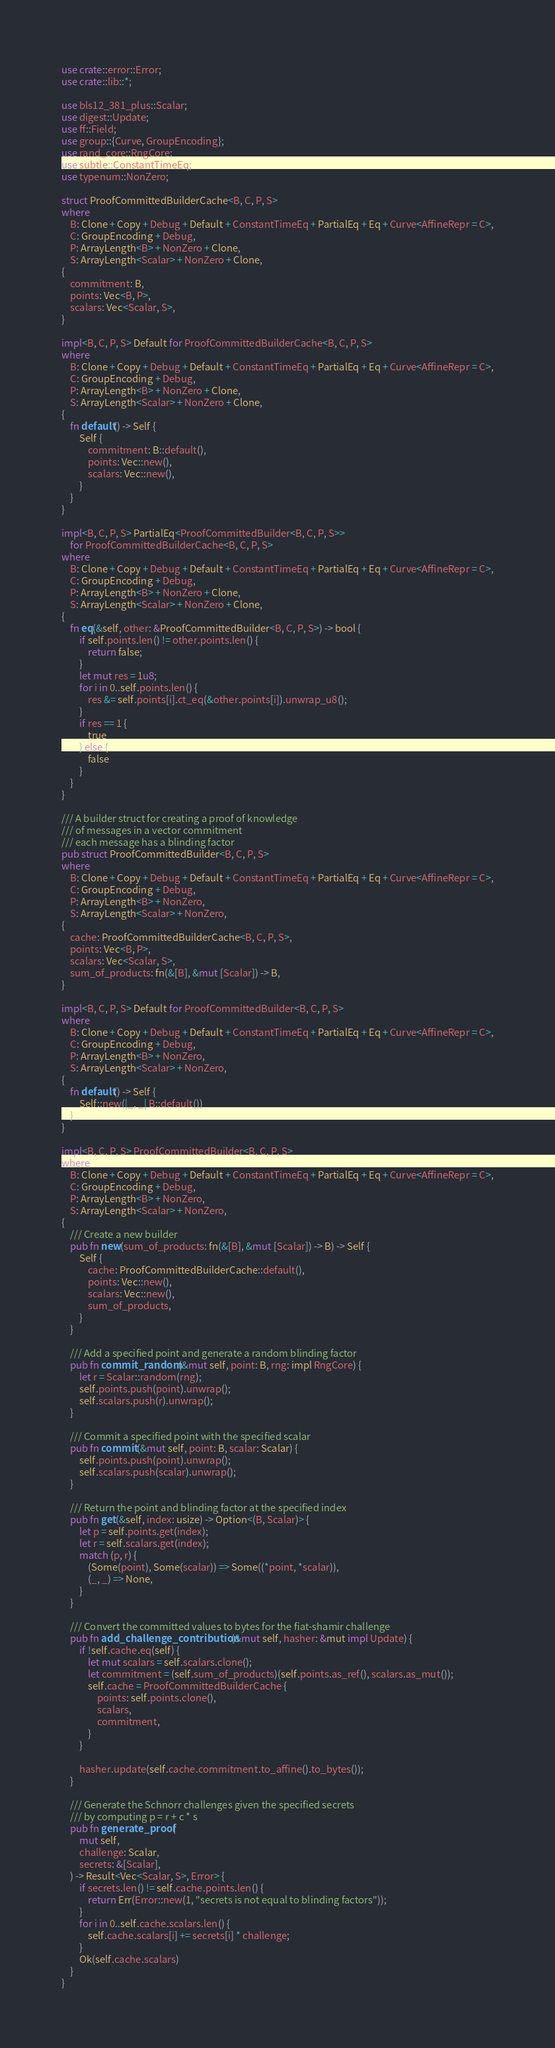<code> <loc_0><loc_0><loc_500><loc_500><_Rust_>use crate::error::Error;
use crate::lib::*;

use bls12_381_plus::Scalar;
use digest::Update;
use ff::Field;
use group::{Curve, GroupEncoding};
use rand_core::RngCore;
use subtle::ConstantTimeEq;
use typenum::NonZero;

struct ProofCommittedBuilderCache<B, C, P, S>
where
    B: Clone + Copy + Debug + Default + ConstantTimeEq + PartialEq + Eq + Curve<AffineRepr = C>,
    C: GroupEncoding + Debug,
    P: ArrayLength<B> + NonZero + Clone,
    S: ArrayLength<Scalar> + NonZero + Clone,
{
    commitment: B,
    points: Vec<B, P>,
    scalars: Vec<Scalar, S>,
}

impl<B, C, P, S> Default for ProofCommittedBuilderCache<B, C, P, S>
where
    B: Clone + Copy + Debug + Default + ConstantTimeEq + PartialEq + Eq + Curve<AffineRepr = C>,
    C: GroupEncoding + Debug,
    P: ArrayLength<B> + NonZero + Clone,
    S: ArrayLength<Scalar> + NonZero + Clone,
{
    fn default() -> Self {
        Self {
            commitment: B::default(),
            points: Vec::new(),
            scalars: Vec::new(),
        }
    }
}

impl<B, C, P, S> PartialEq<ProofCommittedBuilder<B, C, P, S>>
    for ProofCommittedBuilderCache<B, C, P, S>
where
    B: Clone + Copy + Debug + Default + ConstantTimeEq + PartialEq + Eq + Curve<AffineRepr = C>,
    C: GroupEncoding + Debug,
    P: ArrayLength<B> + NonZero + Clone,
    S: ArrayLength<Scalar> + NonZero + Clone,
{
    fn eq(&self, other: &ProofCommittedBuilder<B, C, P, S>) -> bool {
        if self.points.len() != other.points.len() {
            return false;
        }
        let mut res = 1u8;
        for i in 0..self.points.len() {
            res &= self.points[i].ct_eq(&other.points[i]).unwrap_u8();
        }
        if res == 1 {
            true
        } else {
            false
        }
    }
}

/// A builder struct for creating a proof of knowledge
/// of messages in a vector commitment
/// each message has a blinding factor
pub struct ProofCommittedBuilder<B, C, P, S>
where
    B: Clone + Copy + Debug + Default + ConstantTimeEq + PartialEq + Eq + Curve<AffineRepr = C>,
    C: GroupEncoding + Debug,
    P: ArrayLength<B> + NonZero,
    S: ArrayLength<Scalar> + NonZero,
{
    cache: ProofCommittedBuilderCache<B, C, P, S>,
    points: Vec<B, P>,
    scalars: Vec<Scalar, S>,
    sum_of_products: fn(&[B], &mut [Scalar]) -> B,
}

impl<B, C, P, S> Default for ProofCommittedBuilder<B, C, P, S>
where
    B: Clone + Copy + Debug + Default + ConstantTimeEq + PartialEq + Eq + Curve<AffineRepr = C>,
    C: GroupEncoding + Debug,
    P: ArrayLength<B> + NonZero,
    S: ArrayLength<Scalar> + NonZero,
{
    fn default() -> Self {
        Self::new(|_, _| B::default())
    }
}

impl<B, C, P, S> ProofCommittedBuilder<B, C, P, S>
where
    B: Clone + Copy + Debug + Default + ConstantTimeEq + PartialEq + Eq + Curve<AffineRepr = C>,
    C: GroupEncoding + Debug,
    P: ArrayLength<B> + NonZero,
    S: ArrayLength<Scalar> + NonZero,
{
    /// Create a new builder
    pub fn new(sum_of_products: fn(&[B], &mut [Scalar]) -> B) -> Self {
        Self {
            cache: ProofCommittedBuilderCache::default(),
            points: Vec::new(),
            scalars: Vec::new(),
            sum_of_products,
        }
    }

    /// Add a specified point and generate a random blinding factor
    pub fn commit_random(&mut self, point: B, rng: impl RngCore) {
        let r = Scalar::random(rng);
        self.points.push(point).unwrap();
        self.scalars.push(r).unwrap();
    }

    /// Commit a specified point with the specified scalar
    pub fn commit(&mut self, point: B, scalar: Scalar) {
        self.points.push(point).unwrap();
        self.scalars.push(scalar).unwrap();
    }

    /// Return the point and blinding factor at the specified index
    pub fn get(&self, index: usize) -> Option<(B, Scalar)> {
        let p = self.points.get(index);
        let r = self.scalars.get(index);
        match (p, r) {
            (Some(point), Some(scalar)) => Some((*point, *scalar)),
            (_, _) => None,
        }
    }

    /// Convert the committed values to bytes for the fiat-shamir challenge
    pub fn add_challenge_contribution(&mut self, hasher: &mut impl Update) {
        if !self.cache.eq(self) {
            let mut scalars = self.scalars.clone();
            let commitment = (self.sum_of_products)(self.points.as_ref(), scalars.as_mut());
            self.cache = ProofCommittedBuilderCache {
                points: self.points.clone(),
                scalars,
                commitment,
            }
        }

        hasher.update(self.cache.commitment.to_affine().to_bytes());
    }

    /// Generate the Schnorr challenges given the specified secrets
    /// by computing p = r + c * s
    pub fn generate_proof(
        mut self,
        challenge: Scalar,
        secrets: &[Scalar],
    ) -> Result<Vec<Scalar, S>, Error> {
        if secrets.len() != self.cache.points.len() {
            return Err(Error::new(1, "secrets is not equal to blinding factors"));
        }
        for i in 0..self.cache.scalars.len() {
            self.cache.scalars[i] += secrets[i] * challenge;
        }
        Ok(self.cache.scalars)
    }
}
</code> 